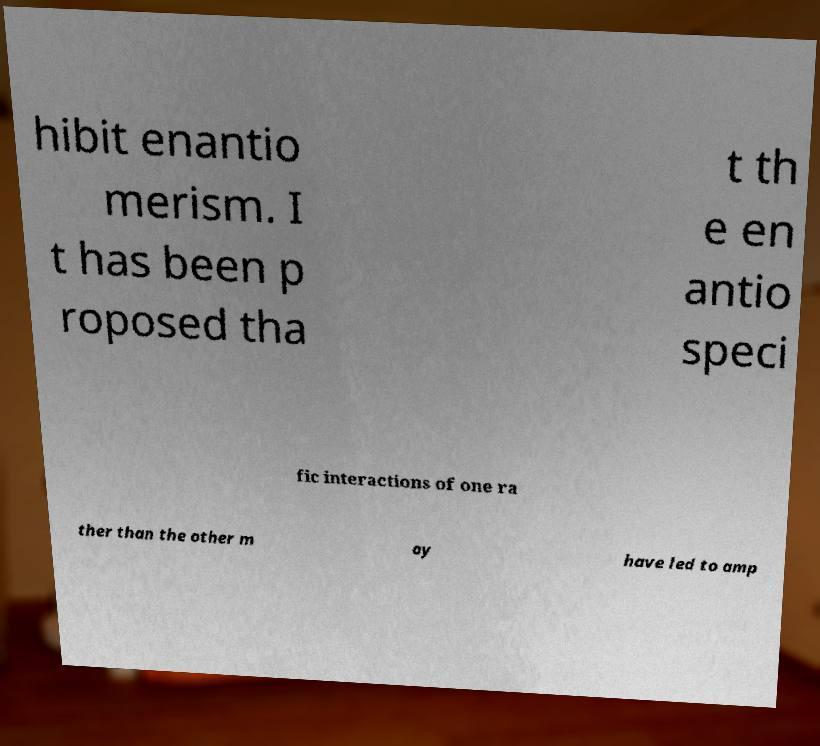Please identify and transcribe the text found in this image. hibit enantio merism. I t has been p roposed tha t th e en antio speci fic interactions of one ra ther than the other m ay have led to amp 